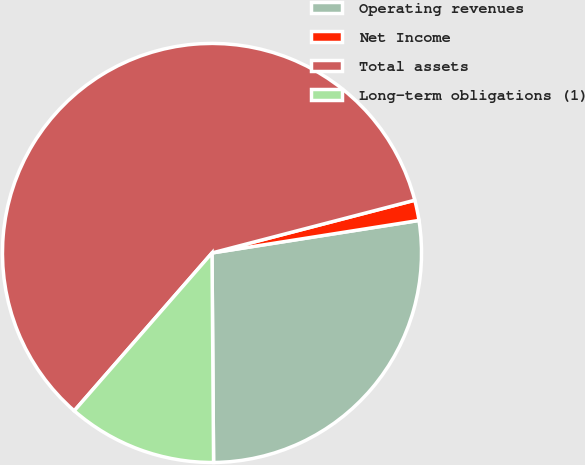Convert chart. <chart><loc_0><loc_0><loc_500><loc_500><pie_chart><fcel>Operating revenues<fcel>Net Income<fcel>Total assets<fcel>Long-term obligations (1)<nl><fcel>27.36%<fcel>1.57%<fcel>59.53%<fcel>11.54%<nl></chart> 